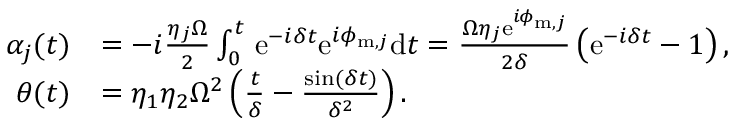Convert formula to latex. <formula><loc_0><loc_0><loc_500><loc_500>\begin{array} { r l } { \alpha _ { j } ( t ) } & { = - i \frac { \eta _ { j } \Omega } { 2 } \int _ { 0 } ^ { t } \, e ^ { - i \delta t } e ^ { i \phi _ { m , j } } d t = \frac { \Omega \eta _ { j } e ^ { i \phi _ { m , j } } } { 2 \delta } \left ( e ^ { - i \delta t } - 1 \right ) , } \\ { \theta ( t ) } & { = \eta _ { 1 } \eta _ { 2 } \Omega ^ { 2 } \left ( \frac { t } { \delta } - \frac { \sin ( \delta t ) } { \delta ^ { 2 } } \right ) . } \end{array}</formula> 